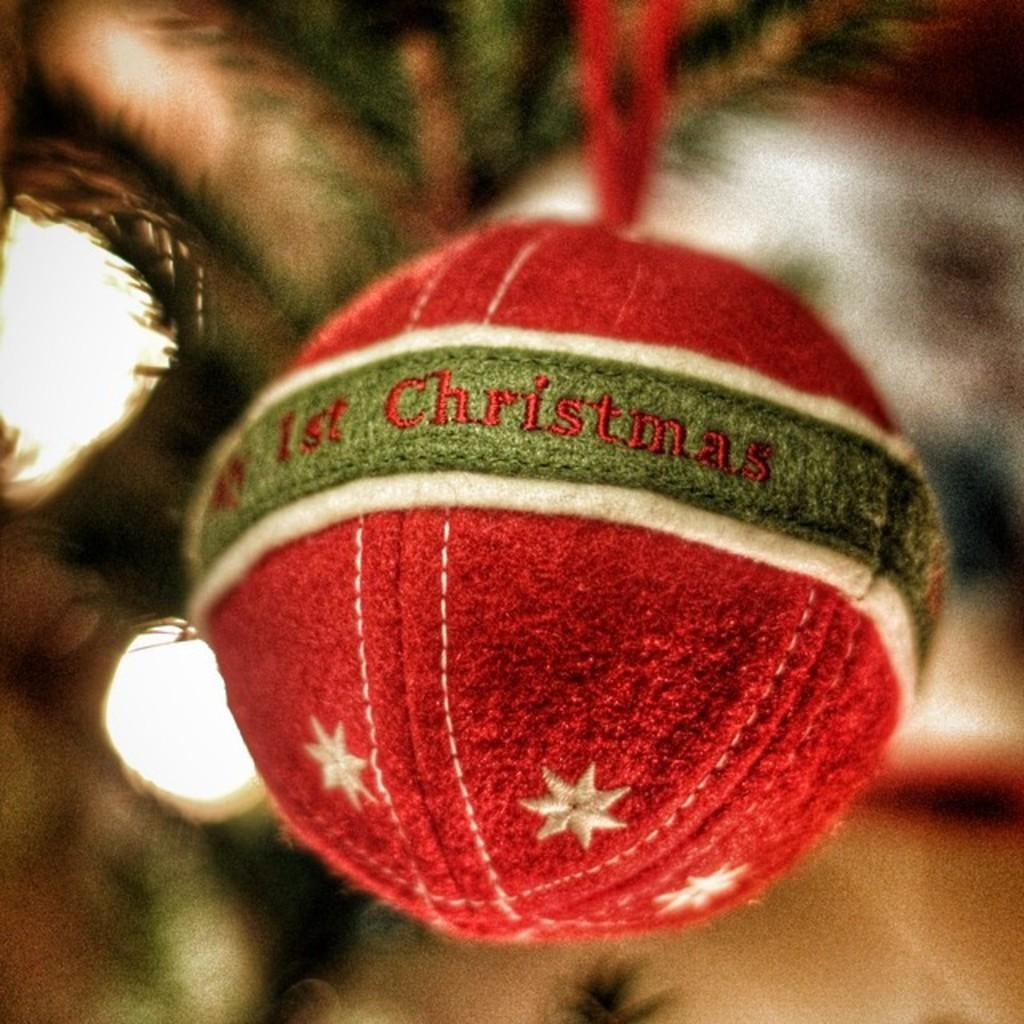What is the main object in the center of the image? There is a red color Christmas ornament in the image, and it is in the middle of the image. What is the background of the image? There is a Christmas tree in the background of the image. What feature does the Christmas tree have? The Christmas tree has lights. What design element is present on the Christmas ornament? There are stars on the Christmas ornament. What type of authority figure can be seen in the image? There is no authority figure present in the image; it features a red color Christmas ornament and a Christmas tree. What kind of stone is used to make the Christmas ornament? The Christmas ornament is not made of stone; it is made of a material suitable for ornaments, such as glass or plastic. 